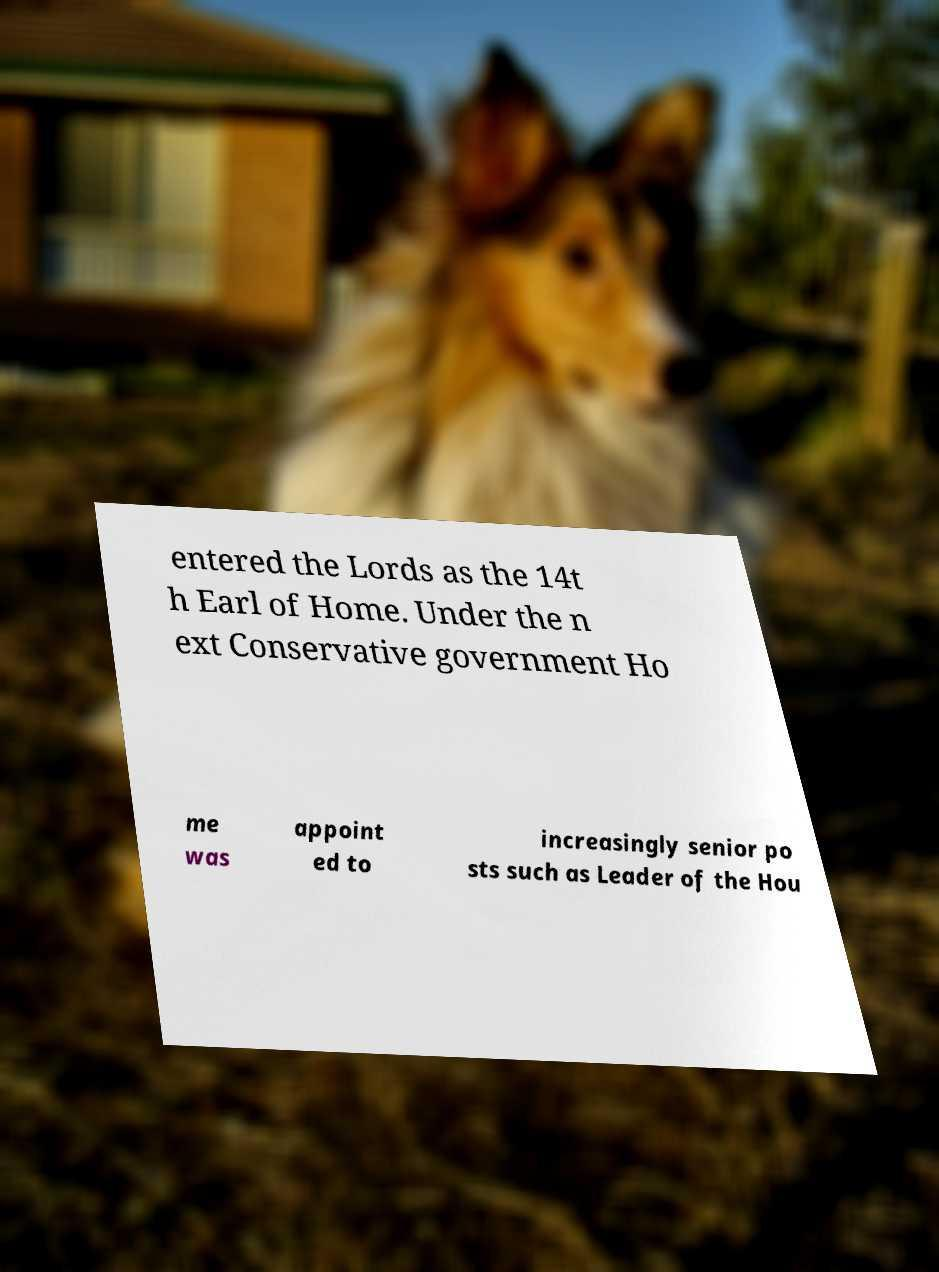Could you assist in decoding the text presented in this image and type it out clearly? entered the Lords as the 14t h Earl of Home. Under the n ext Conservative government Ho me was appoint ed to increasingly senior po sts such as Leader of the Hou 